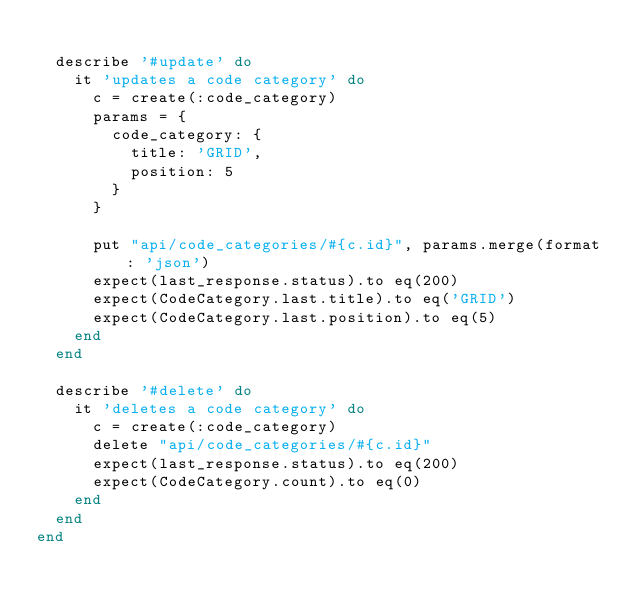<code> <loc_0><loc_0><loc_500><loc_500><_Ruby_>
  describe '#update' do
    it 'updates a code category' do
      c = create(:code_category)
      params = {
        code_category: {
          title: 'GRID',
          position: 5
        }
      }

      put "api/code_categories/#{c.id}", params.merge(format: 'json')
      expect(last_response.status).to eq(200)
      expect(CodeCategory.last.title).to eq('GRID')
      expect(CodeCategory.last.position).to eq(5)
    end
  end

  describe '#delete' do
    it 'deletes a code category' do
      c = create(:code_category)
      delete "api/code_categories/#{c.id}"
      expect(last_response.status).to eq(200)
      expect(CodeCategory.count).to eq(0)
    end
  end
end
</code> 